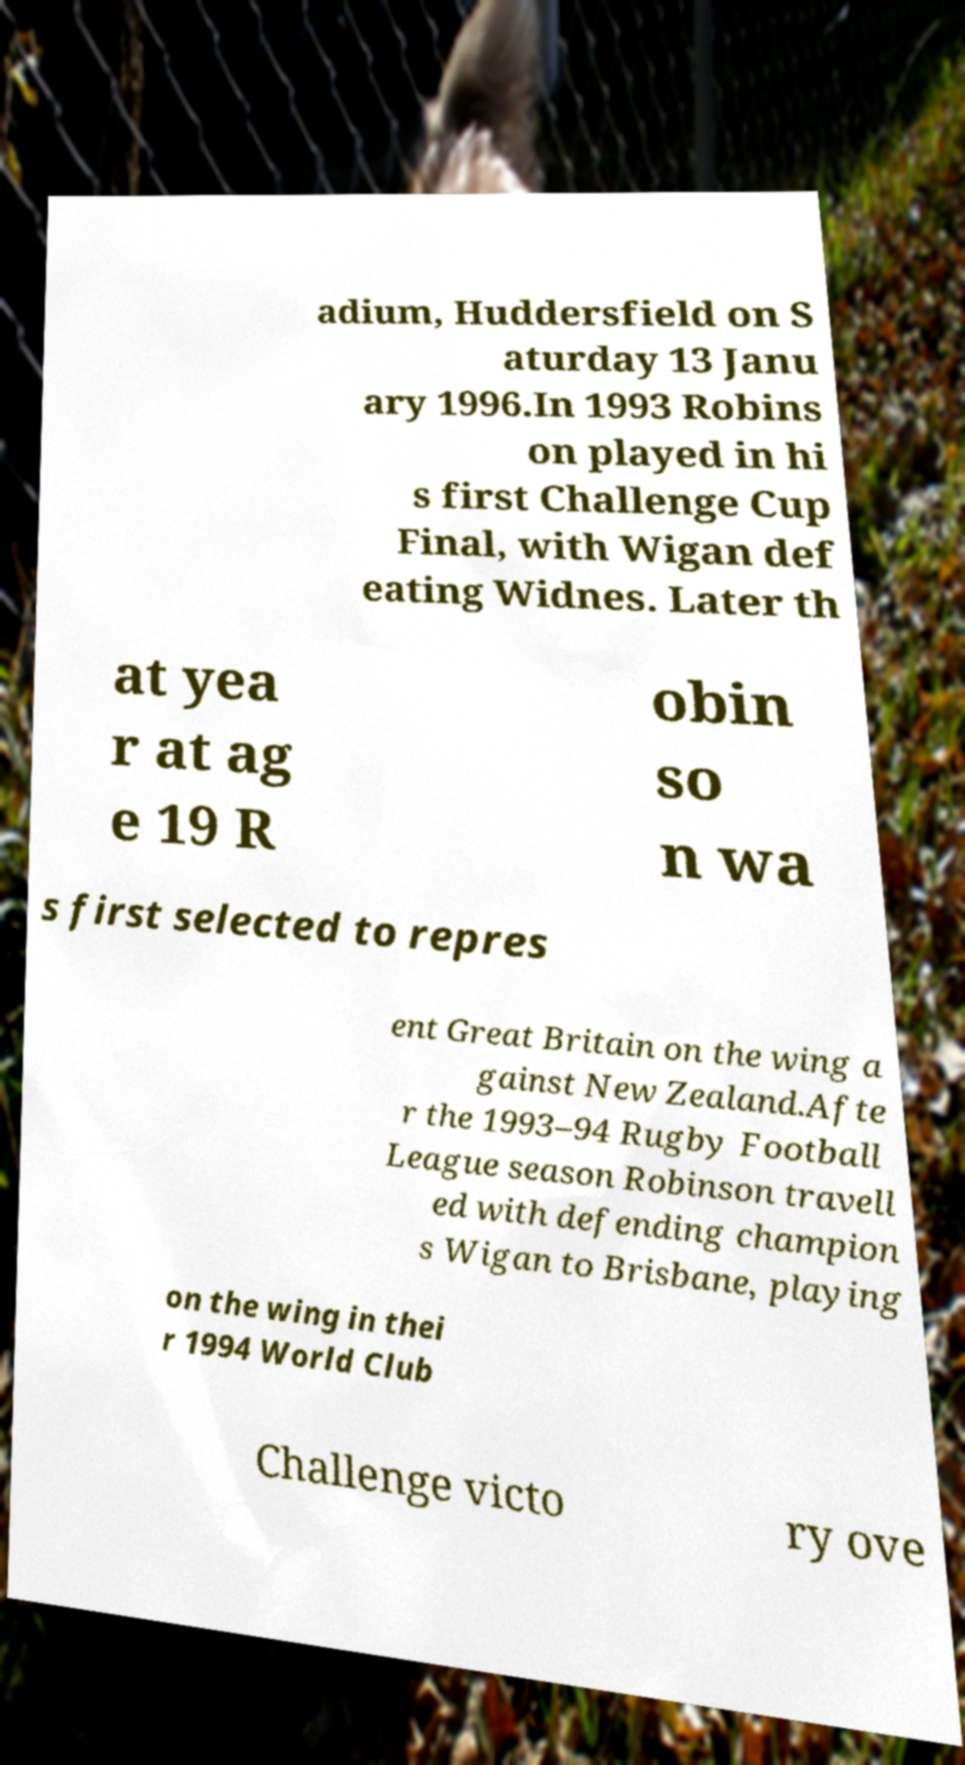Could you extract and type out the text from this image? adium, Huddersfield on S aturday 13 Janu ary 1996.In 1993 Robins on played in hi s first Challenge Cup Final, with Wigan def eating Widnes. Later th at yea r at ag e 19 R obin so n wa s first selected to repres ent Great Britain on the wing a gainst New Zealand.Afte r the 1993–94 Rugby Football League season Robinson travell ed with defending champion s Wigan to Brisbane, playing on the wing in thei r 1994 World Club Challenge victo ry ove 